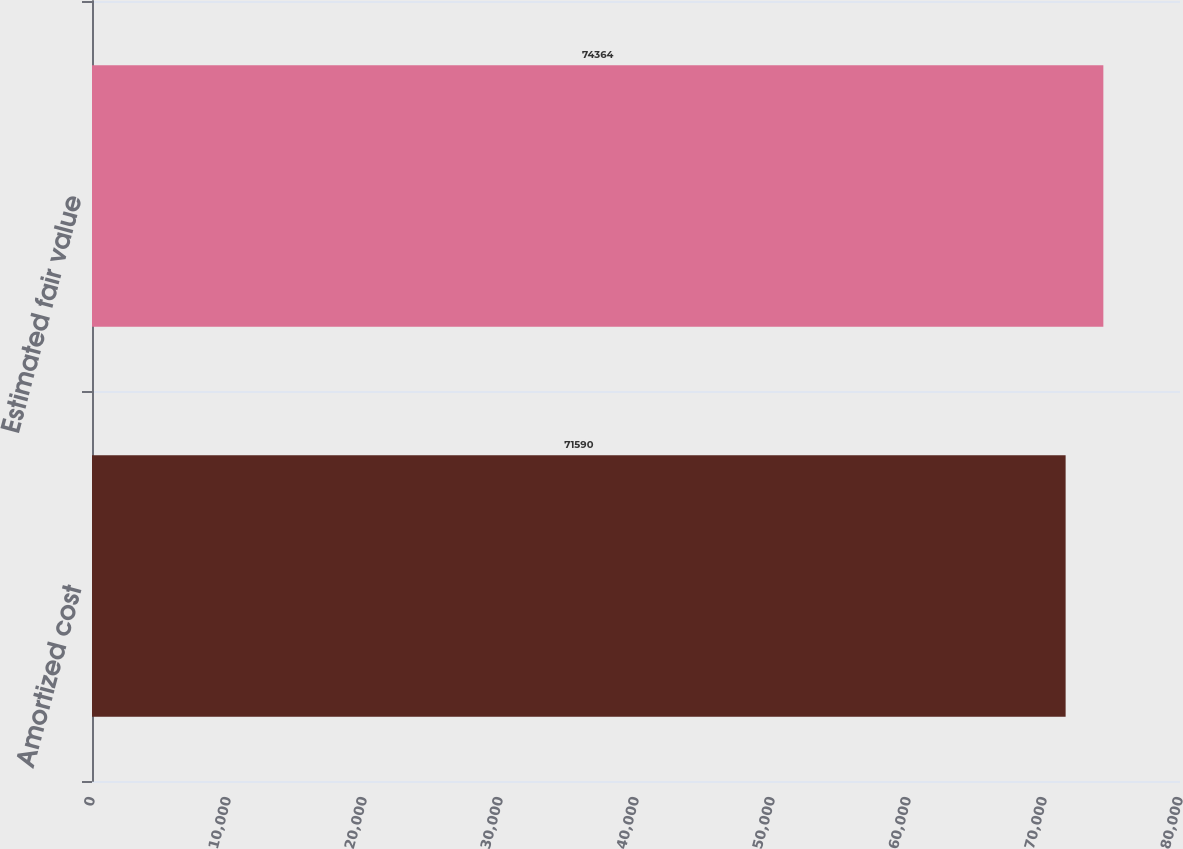Convert chart. <chart><loc_0><loc_0><loc_500><loc_500><bar_chart><fcel>Amortized cost<fcel>Estimated fair value<nl><fcel>71590<fcel>74364<nl></chart> 